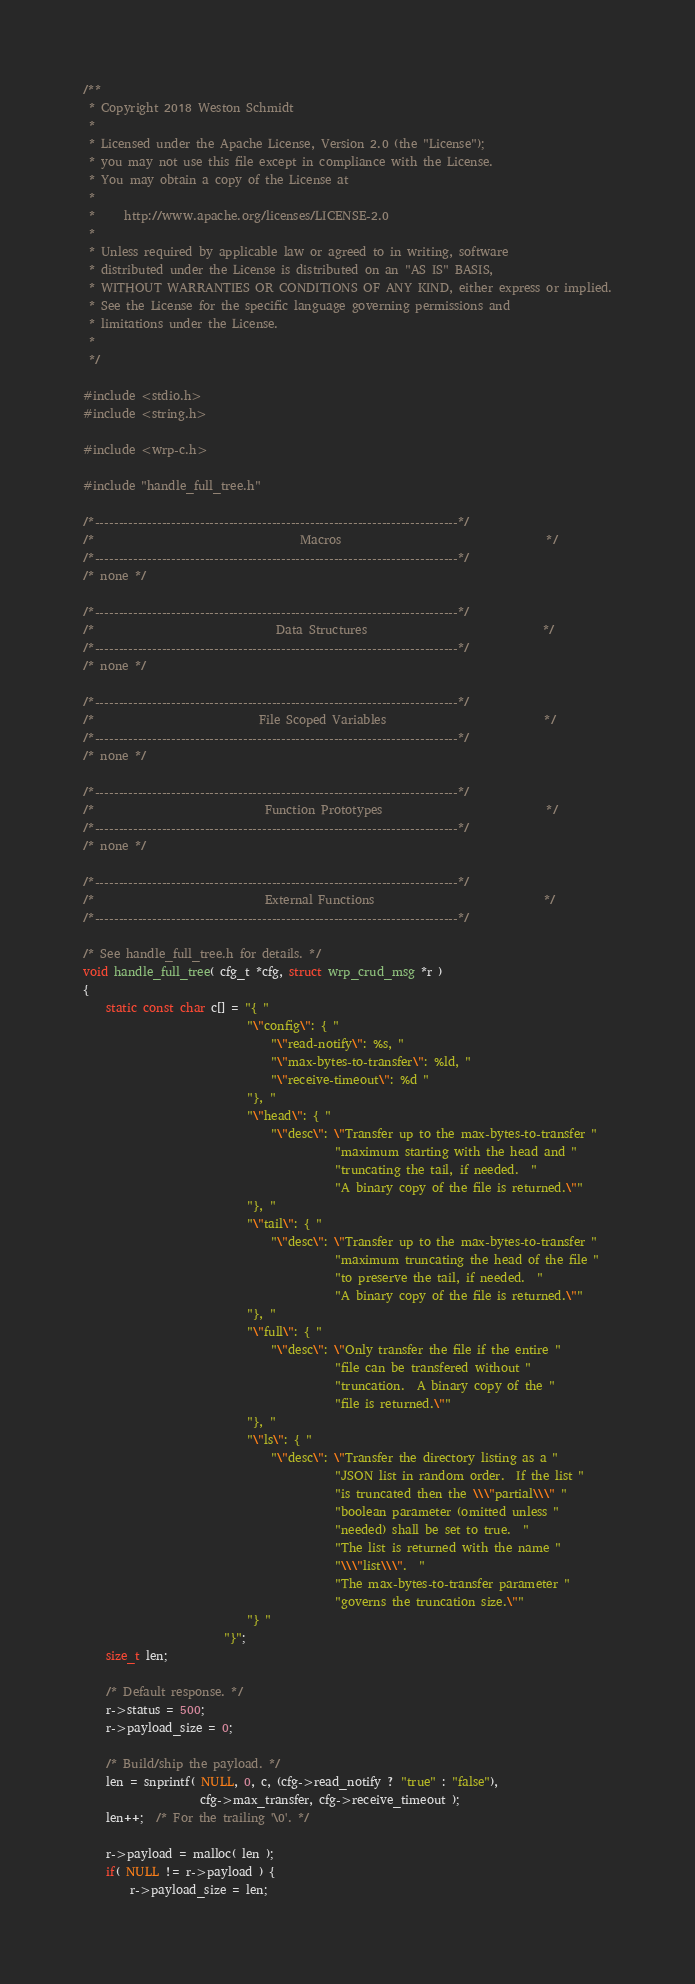Convert code to text. <code><loc_0><loc_0><loc_500><loc_500><_C_>/**
 * Copyright 2018 Weston Schmidt
 *
 * Licensed under the Apache License, Version 2.0 (the "License");
 * you may not use this file except in compliance with the License.
 * You may obtain a copy of the License at
 *
 *     http://www.apache.org/licenses/LICENSE-2.0
 *
 * Unless required by applicable law or agreed to in writing, software
 * distributed under the License is distributed on an "AS IS" BASIS,
 * WITHOUT WARRANTIES OR CONDITIONS OF ANY KIND, either express or implied.
 * See the License for the specific language governing permissions and
 * limitations under the License.
 *
 */

#include <stdio.h>
#include <string.h>

#include <wrp-c.h>

#include "handle_full_tree.h"

/*----------------------------------------------------------------------------*/
/*                                   Macros                                   */
/*----------------------------------------------------------------------------*/
/* none */

/*----------------------------------------------------------------------------*/
/*                               Data Structures                              */
/*----------------------------------------------------------------------------*/
/* none */

/*----------------------------------------------------------------------------*/
/*                            File Scoped Variables                           */
/*----------------------------------------------------------------------------*/
/* none */

/*----------------------------------------------------------------------------*/
/*                             Function Prototypes                            */
/*----------------------------------------------------------------------------*/
/* none */

/*----------------------------------------------------------------------------*/
/*                             External Functions                             */
/*----------------------------------------------------------------------------*/

/* See handle_full_tree.h for details. */
void handle_full_tree( cfg_t *cfg, struct wrp_crud_msg *r )
{
    static const char c[] = "{ "
                            "\"config\": { "
                                "\"read-notify\": %s, "
                                "\"max-bytes-to-transfer\": %ld, "
                                "\"receive-timeout\": %d "
                            "}, "
                            "\"head\": { "
                                "\"desc\": \"Transfer up to the max-bytes-to-transfer "
                                           "maximum starting with the head and "
                                           "truncating the tail, if needed.  "
                                           "A binary copy of the file is returned.\""
                            "}, "
                            "\"tail\": { "
                                "\"desc\": \"Transfer up to the max-bytes-to-transfer "
                                           "maximum truncating the head of the file "
                                           "to preserve the tail, if needed.  "
                                           "A binary copy of the file is returned.\""
                            "}, "
                            "\"full\": { "
                                "\"desc\": \"Only transfer the file if the entire "
                                           "file can be transfered without "
                                           "truncation.  A binary copy of the "
                                           "file is returned.\""
                            "}, "
                            "\"ls\": { "
                                "\"desc\": \"Transfer the directory listing as a "
                                           "JSON list in random order.  If the list "
                                           "is truncated then the \\\"partial\\\" "
                                           "boolean parameter (omitted unless "
                                           "needed) shall be set to true.  "
                                           "The list is returned with the name "
                                           "\\\"list\\\".  "
                                           "The max-bytes-to-transfer parameter "
                                           "governs the truncation size.\""
                            "} "
                        "}";
    size_t len;

    /* Default response. */
    r->status = 500;
    r->payload_size = 0;

    /* Build/ship the payload. */
    len = snprintf( NULL, 0, c, (cfg->read_notify ? "true" : "false"),
                    cfg->max_transfer, cfg->receive_timeout );
    len++;  /* For the trailing '\0'. */
                                                                  
    r->payload = malloc( len );
    if( NULL != r->payload ) {
        r->payload_size = len;</code> 